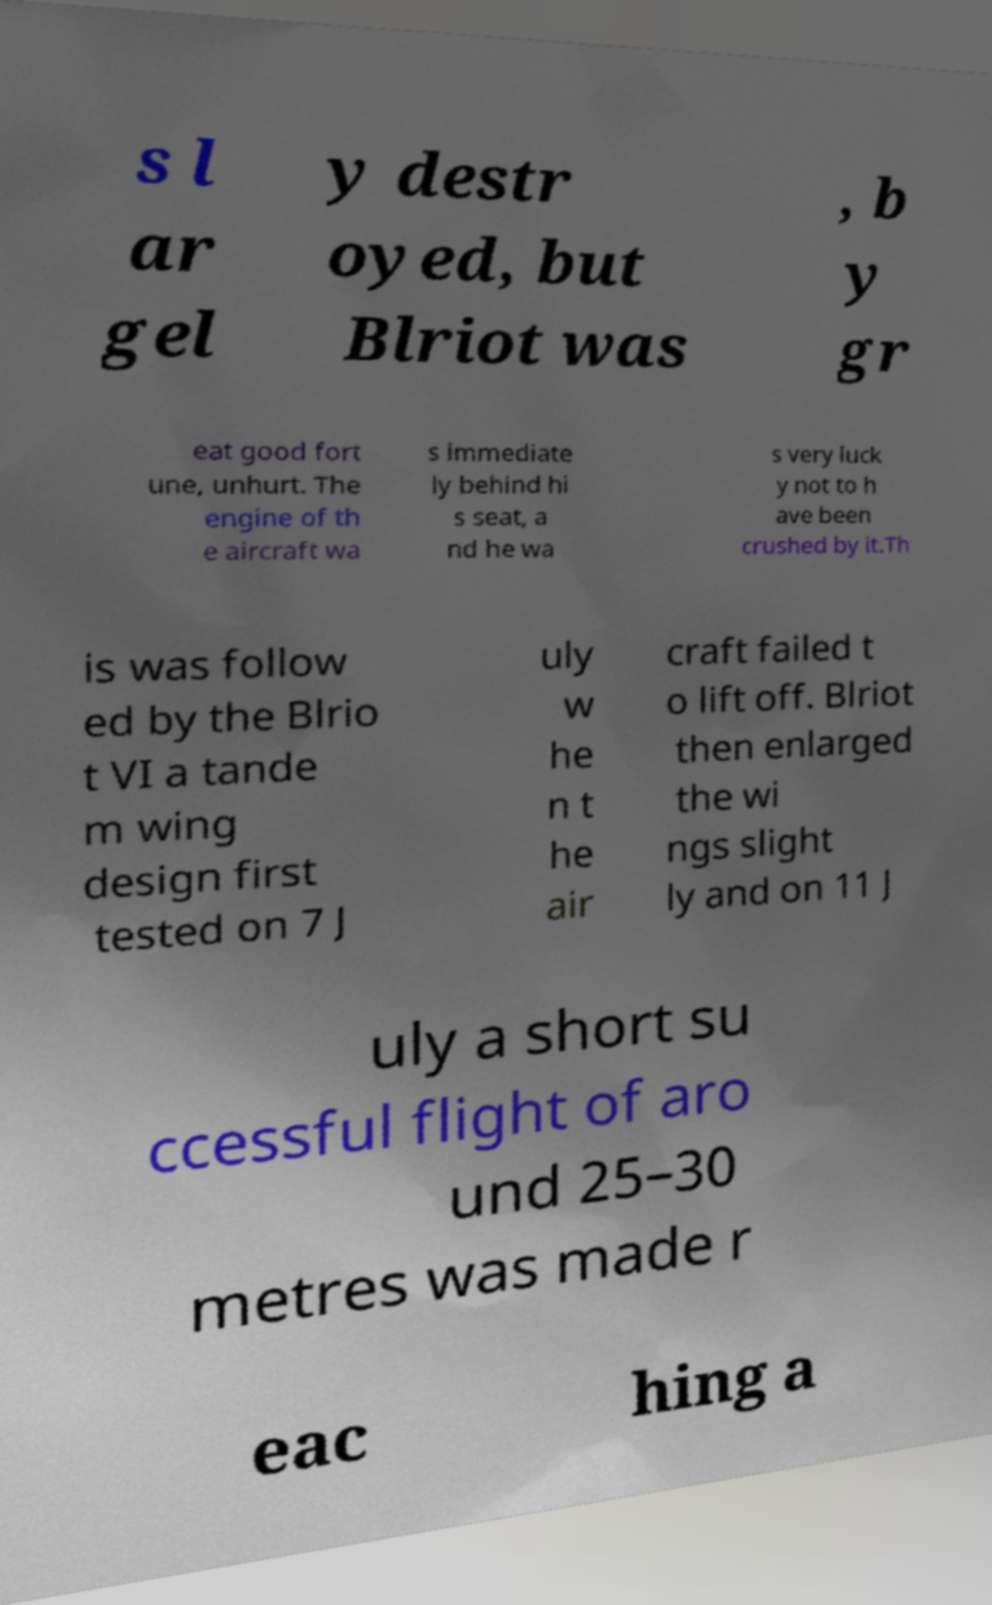For documentation purposes, I need the text within this image transcribed. Could you provide that? s l ar gel y destr oyed, but Blriot was , b y gr eat good fort une, unhurt. The engine of th e aircraft wa s immediate ly behind hi s seat, a nd he wa s very luck y not to h ave been crushed by it.Th is was follow ed by the Blrio t VI a tande m wing design first tested on 7 J uly w he n t he air craft failed t o lift off. Blriot then enlarged the wi ngs slight ly and on 11 J uly a short su ccessful flight of aro und 25–30 metres was made r eac hing a 